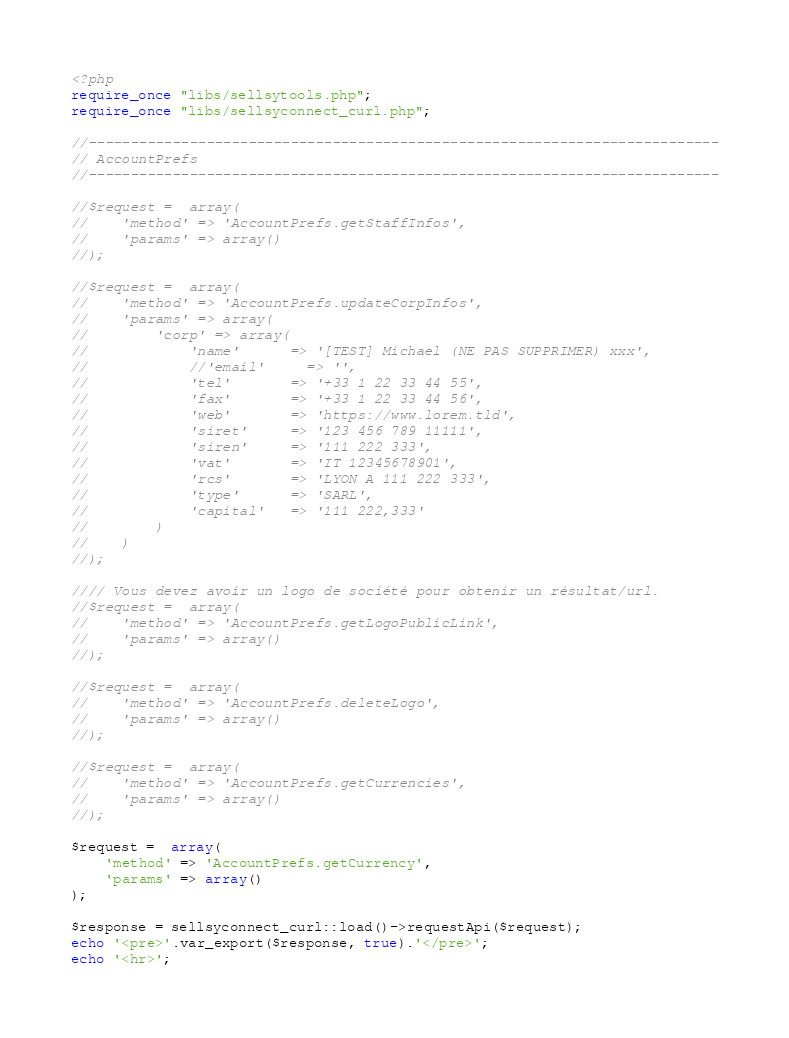<code> <loc_0><loc_0><loc_500><loc_500><_PHP_><?php
require_once "libs/sellsytools.php";
require_once "libs/sellsyconnect_curl.php";

//---------------------------------------------------------------------------
// AccountPrefs
//---------------------------------------------------------------------------

//$request =  array( 
//    'method' => 'AccountPrefs.getStaffInfos',
//    'params' => array()
//);

//$request =  array(
//    'method' => 'AccountPrefs.updateCorpInfos',
//    'params' => array(
//        'corp' => array(
//            'name'      => '[TEST] Michael (NE PAS SUPPRIMER) xxx',
//            //'email'     => '',
//            'tel'       => '+33 1 22 33 44 55',
//            'fax'       => '+33 1 22 33 44 56',
//            'web'       => 'https://www.lorem.tld',
//            'siret'     => '123 456 789 11111',
//            'siren'     => '111 222 333',
//            'vat'       => 'IT 12345678901',
//            'rcs'       => 'LYON A 111 222 333',
//            'type'      => 'SARL',
//            'capital'   => '111 222,333'
//        )
//    )
//);

//// Vous devez avoir un logo de société pour obtenir un résultat/url.
//$request =  array(
//    'method' => 'AccountPrefs.getLogoPublicLink',
//    'params' => array()
//);

//$request =  array(
//    'method' => 'AccountPrefs.deleteLogo',
//    'params' => array()
//);

//$request =  array(
//    'method' => 'AccountPrefs.getCurrencies',
//    'params' => array()
//);

$request =  array(
    'method' => 'AccountPrefs.getCurrency',
    'params' => array()
);

$response = sellsyconnect_curl::load()->requestApi($request);
echo '<pre>'.var_export($response, true).'</pre>';
echo '<hr>';
</code> 